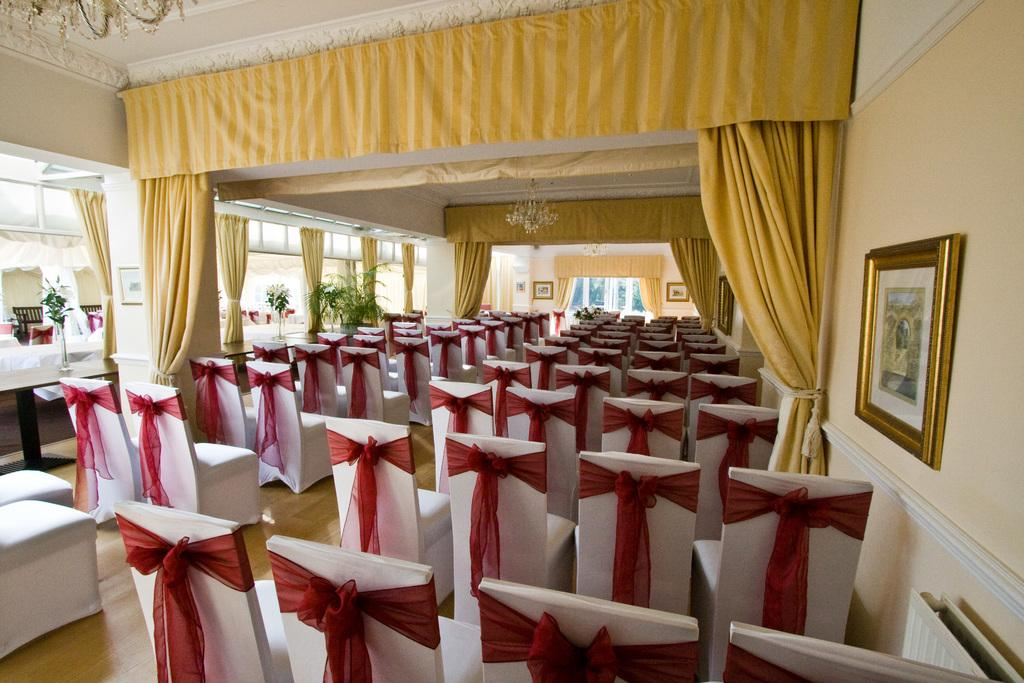What type of space is depicted in the image? The image shows an inside view of a hall. What furniture can be seen in the hall? There are chairs in the hall. What type of decoration is present in the hall? There is a curtain and a frame in the hall. What other elements can be found in the hall? There are plants and a wall in the hall. What type of wool is used to make the ticket in the image? There is no ticket or wool present in the image. Who is the uncle in the image? There is no uncle depicted in the image. 